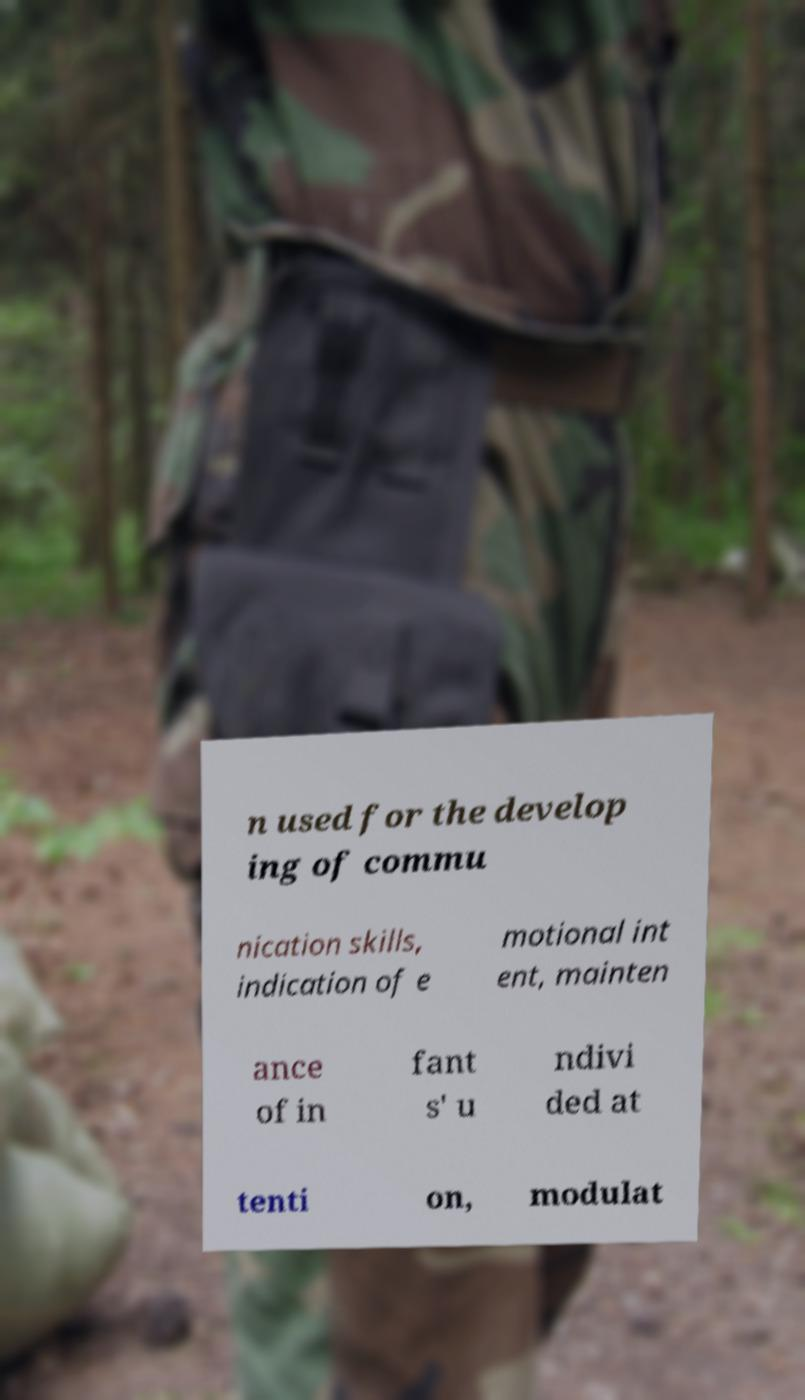There's text embedded in this image that I need extracted. Can you transcribe it verbatim? n used for the develop ing of commu nication skills, indication of e motional int ent, mainten ance of in fant s' u ndivi ded at tenti on, modulat 